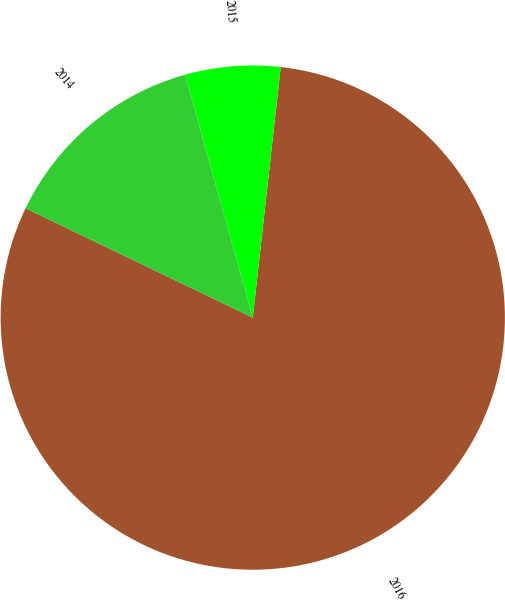Convert chart to OTSL. <chart><loc_0><loc_0><loc_500><loc_500><pie_chart><fcel>2016<fcel>2015<fcel>2014<nl><fcel>80.37%<fcel>6.1%<fcel>13.53%<nl></chart> 